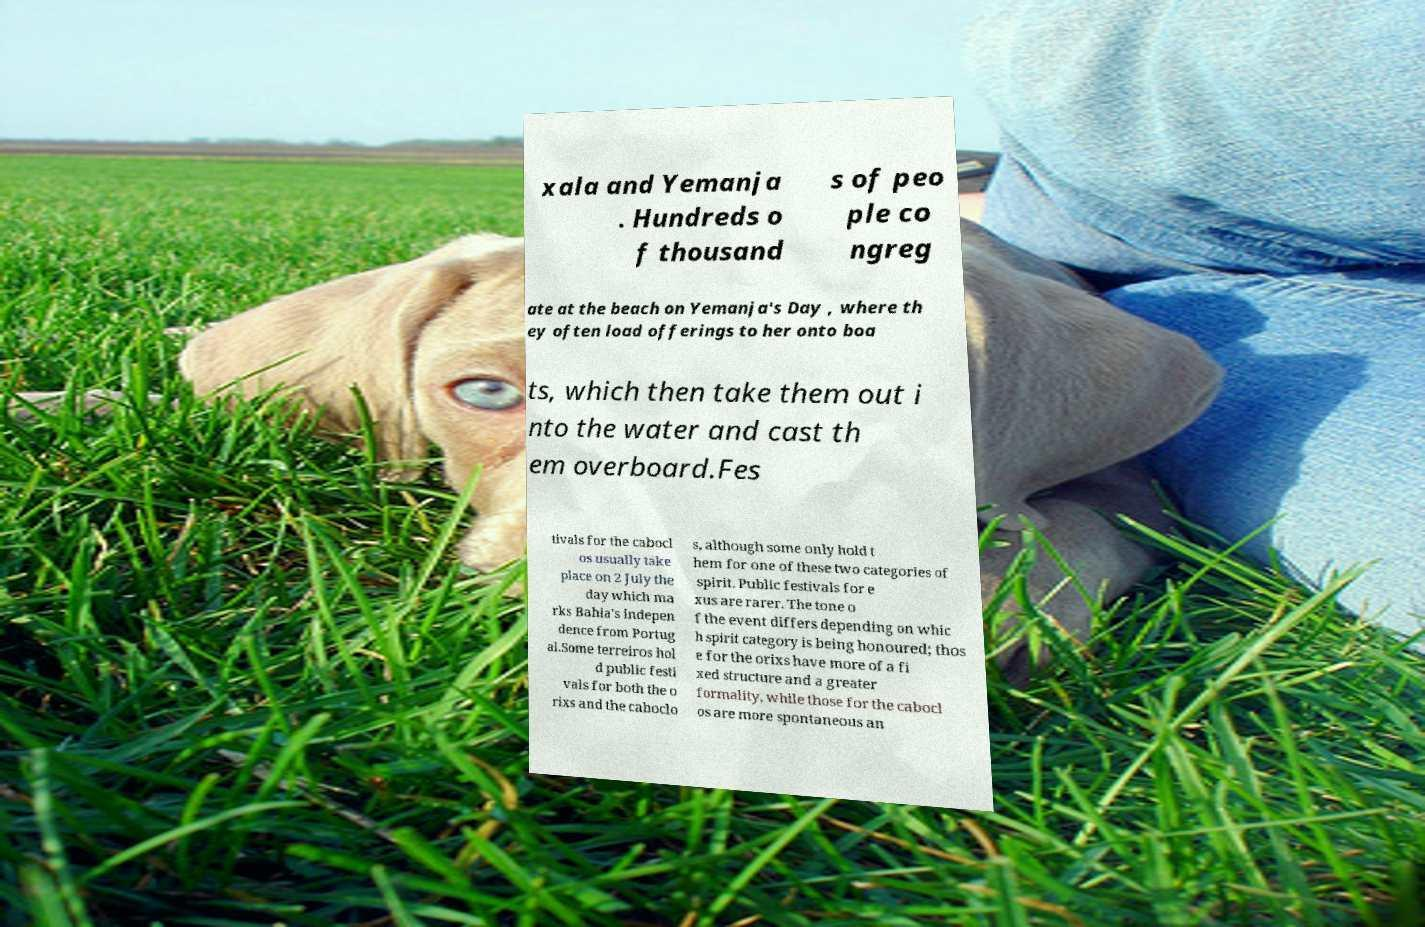Please identify and transcribe the text found in this image. xala and Yemanja . Hundreds o f thousand s of peo ple co ngreg ate at the beach on Yemanja's Day , where th ey often load offerings to her onto boa ts, which then take them out i nto the water and cast th em overboard.Fes tivals for the cabocl os usually take place on 2 July the day which ma rks Bahia's indepen dence from Portug al.Some terreiros hol d public festi vals for both the o rixs and the caboclo s, although some only hold t hem for one of these two categories of spirit. Public festivals for e xus are rarer. The tone o f the event differs depending on whic h spirit category is being honoured; thos e for the orixs have more of a fi xed structure and a greater formality, while those for the cabocl os are more spontaneous an 